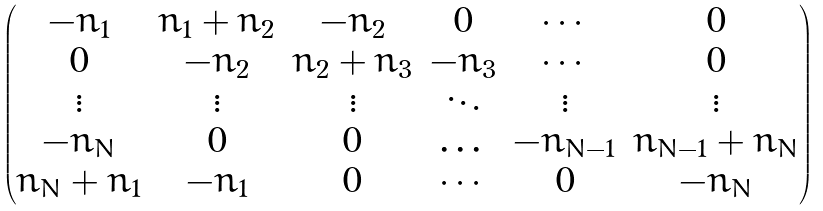<formula> <loc_0><loc_0><loc_500><loc_500>\left ( \begin{matrix} - n _ { 1 } & n _ { 1 } + n _ { 2 } & - n _ { 2 } & 0 & \cdots & 0 \\ 0 & - n _ { 2 } & n _ { 2 } + n _ { 3 } & - n _ { 3 } & \cdots & 0 \\ \vdots & \vdots & \vdots & \ddots & \vdots & \vdots \\ - n _ { N } & 0 & 0 & \dots & - n _ { N - 1 } & n _ { N - 1 } + n _ { N } \\ n _ { N } + n _ { 1 } & - n _ { 1 } & 0 & \cdots & 0 & - n _ { N } \end{matrix} \right )</formula> 